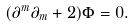<formula> <loc_0><loc_0><loc_500><loc_500>( \partial ^ { m } \partial _ { m } + 2 ) \Phi = 0 .</formula> 